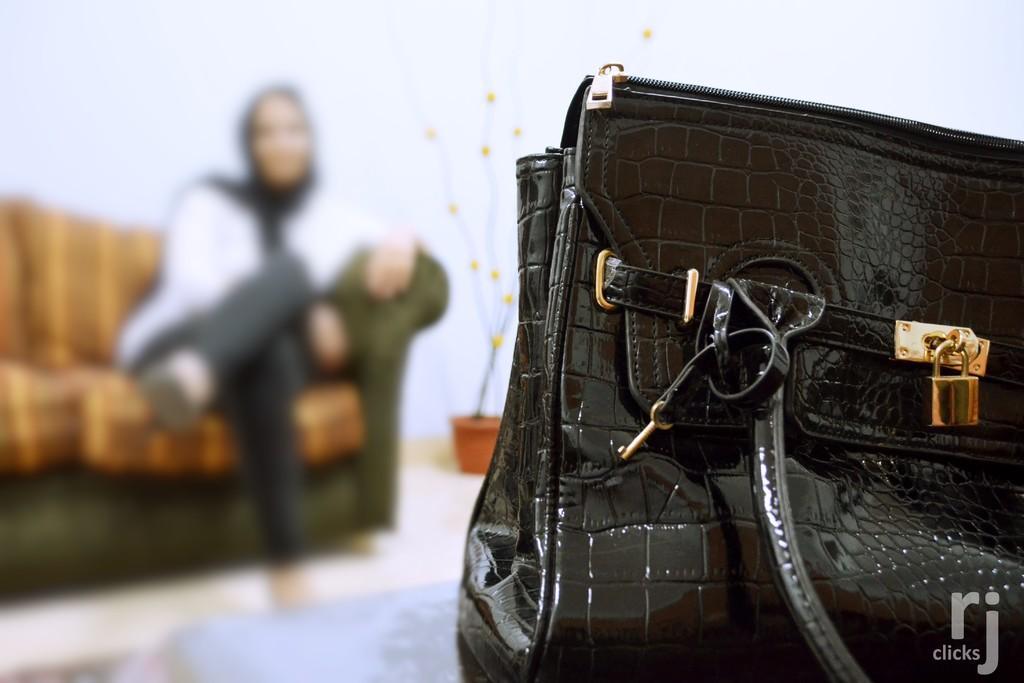Can you describe this image briefly? On the right there is a bag,which is in black color. On the left there is a person sitting on the couch. In the background there is wall and flower pot. 